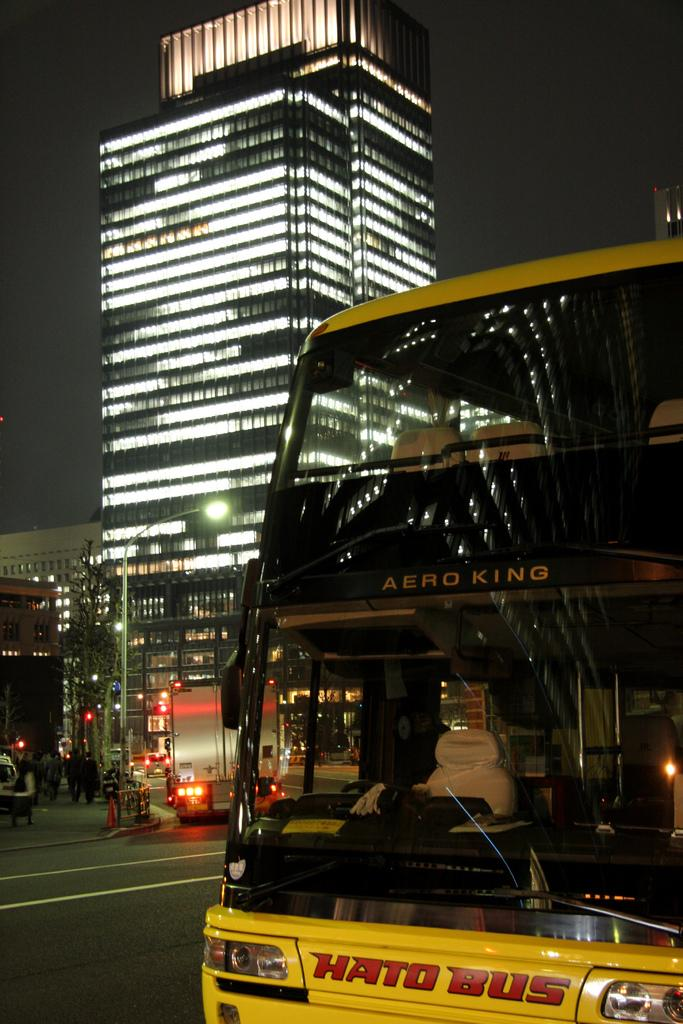<image>
Present a compact description of the photo's key features. A yellow double decker Hato Bus with white seats is parked. 